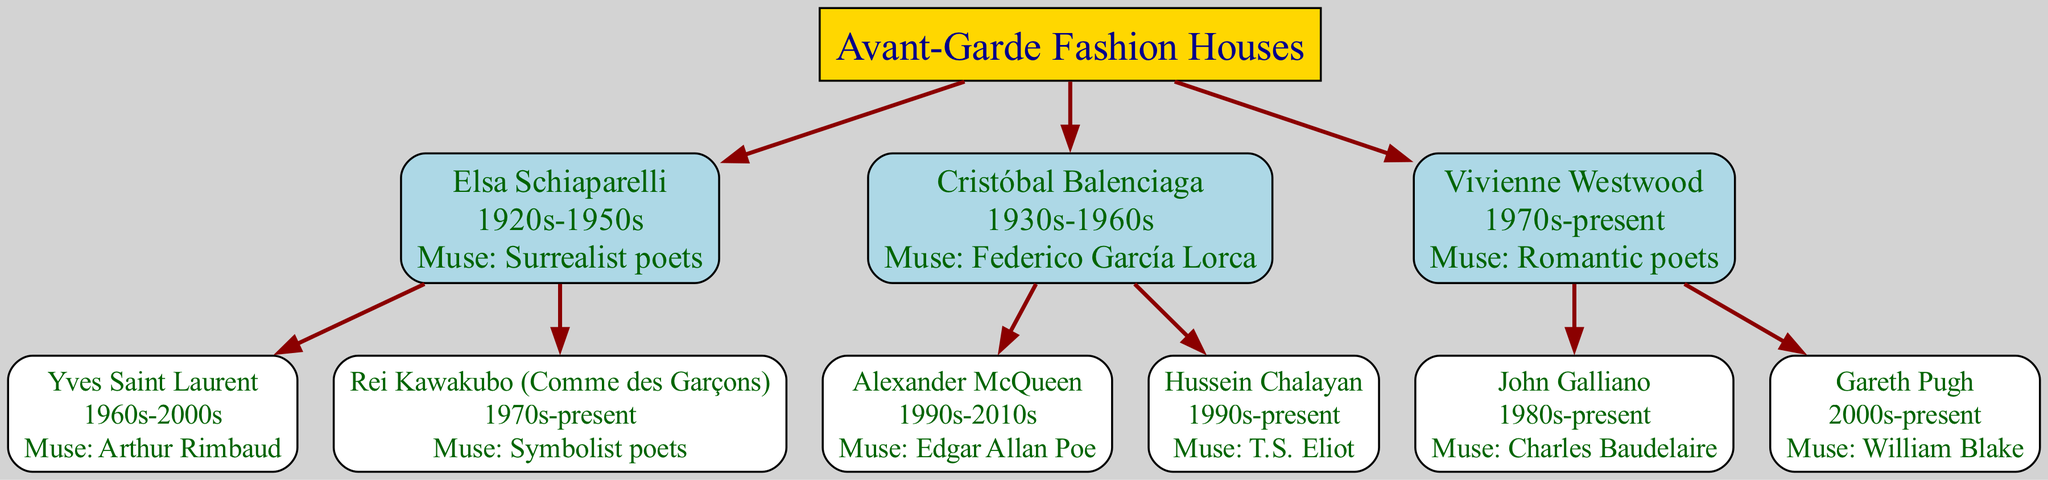What is the root of the family tree? The root of the family tree is indicated at the top of the diagram and it is labeled as "Avant-Garde Fashion Houses."
Answer: Avant-Garde Fashion Houses How many descendants does Vivienne Westwood have? By examining the nodes connected to Vivienne Westwood, there are two descendants listed: John Galliano and Gareth Pugh.
Answer: 2 Who is the muse of Yves Saint Laurent? Yves Saint Laurent's muse is stated directly in the node associated with his name as "Arthur Rimbaud."
Answer: Arthur Rimbaud Which fashion house was inspired by Federico García Lorca? The branch in the diagram shows that Cristóbal Balenciaga's muse is noted as Federico García Lorca, indicating his connection to this poet.
Answer: Cristóbal Balenciaga What era does Rei Kawakubo belong to? The era for Rei Kawakubo is clearly stated within the label of the corresponding node as "1970s-present."
Answer: 1970s-present Which poetic movement is associated with the descendants of Elsa Schiaparelli? To find the poetic movement, we must look at both Yves Saint Laurent and Rei Kawakubo's nodes which indicate their muses: Arthur Rimbaud and Symbolist poets respectively, connecting both descendants to the Symbolist movement.
Answer: Surrealist and Symbolist poets How is Alexander McQueen related to Cristóbal Balenciaga? Alexander McQueen's node shows that he is a descendant of Cristóbal Balenciaga, indicating a direct familial relationship between the two in the context of the fashion lineage.
Answer: Alexander McQueen What is the main theme connecting the fashion houses in the diagram? The main theme across the diagram is how various avant-garde fashion houses have drawn inspiration from notable poets, combining fashion with literary influence as a key characteristic in their design ethos.
Answer: Poetic inspiration Which two muses are shared by descendants of Vivienne Westwood? The descendants of Vivienne Westwood, John Galliano and Gareth Pugh, are inspired by Charles Baudelaire and William Blake respectively, neither of which is the same; hence, they do not share a muse.
Answer: None 